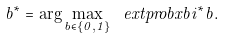Convert formula to latex. <formula><loc_0><loc_0><loc_500><loc_500>b ^ { * } = \arg \max _ { b \in \{ 0 , 1 \} } \ e x t p r o b x { b } { i ^ { * } } { b } .</formula> 